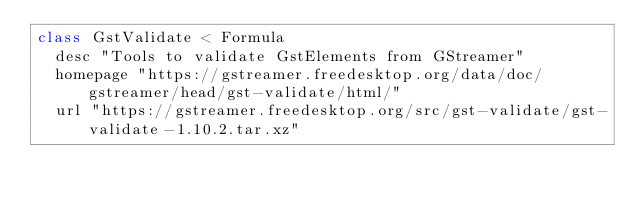<code> <loc_0><loc_0><loc_500><loc_500><_Ruby_>class GstValidate < Formula
  desc "Tools to validate GstElements from GStreamer"
  homepage "https://gstreamer.freedesktop.org/data/doc/gstreamer/head/gst-validate/html/"
  url "https://gstreamer.freedesktop.org/src/gst-validate/gst-validate-1.10.2.tar.xz"</code> 